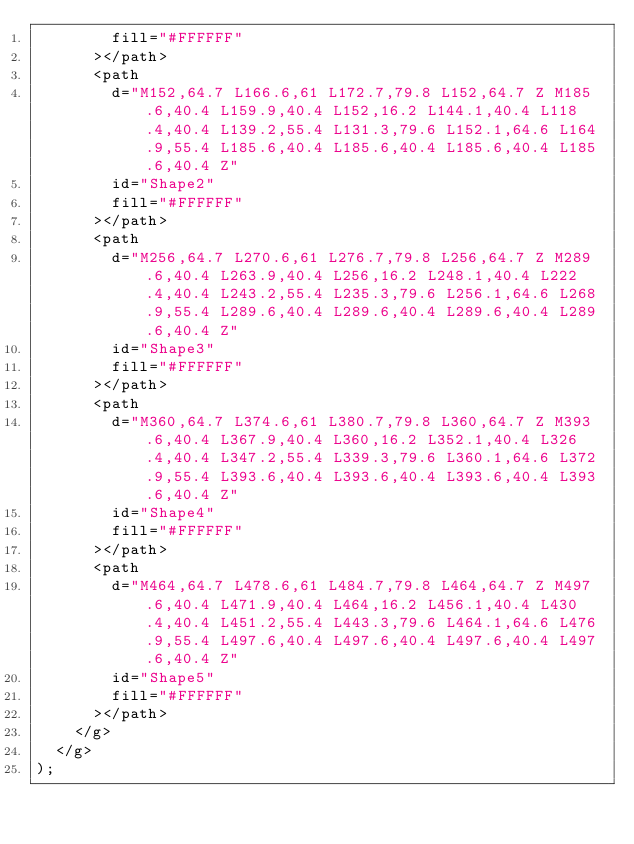<code> <loc_0><loc_0><loc_500><loc_500><_TypeScript_>        fill="#FFFFFF"
      ></path>
      <path
        d="M152,64.7 L166.6,61 L172.7,79.8 L152,64.7 Z M185.6,40.4 L159.9,40.4 L152,16.2 L144.1,40.4 L118.4,40.4 L139.2,55.4 L131.3,79.6 L152.1,64.6 L164.9,55.4 L185.6,40.4 L185.6,40.4 L185.6,40.4 L185.6,40.4 Z"
        id="Shape2"
        fill="#FFFFFF"
      ></path>
      <path
        d="M256,64.7 L270.6,61 L276.7,79.8 L256,64.7 Z M289.6,40.4 L263.9,40.4 L256,16.2 L248.1,40.4 L222.4,40.4 L243.2,55.4 L235.3,79.6 L256.1,64.6 L268.9,55.4 L289.6,40.4 L289.6,40.4 L289.6,40.4 L289.6,40.4 Z"
        id="Shape3"
        fill="#FFFFFF"
      ></path>
      <path
        d="M360,64.7 L374.6,61 L380.7,79.8 L360,64.7 Z M393.6,40.4 L367.9,40.4 L360,16.2 L352.1,40.4 L326.4,40.4 L347.2,55.4 L339.3,79.6 L360.1,64.6 L372.9,55.4 L393.6,40.4 L393.6,40.4 L393.6,40.4 L393.6,40.4 Z"
        id="Shape4"
        fill="#FFFFFF"
      ></path>
      <path
        d="M464,64.7 L478.6,61 L484.7,79.8 L464,64.7 Z M497.6,40.4 L471.9,40.4 L464,16.2 L456.1,40.4 L430.4,40.4 L451.2,55.4 L443.3,79.6 L464.1,64.6 L476.9,55.4 L497.6,40.4 L497.6,40.4 L497.6,40.4 L497.6,40.4 Z"
        id="Shape5"
        fill="#FFFFFF"
      ></path>
    </g>
  </g>
);
</code> 